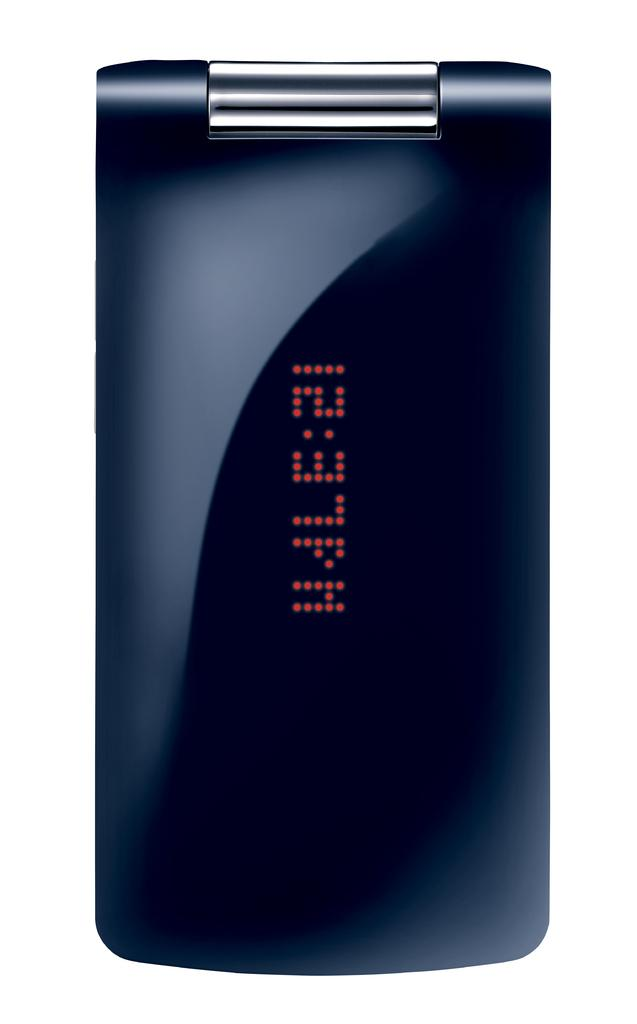<image>
Summarize the visual content of the image. A flip phone with a digital cover displaying the time as 12:37pm. 